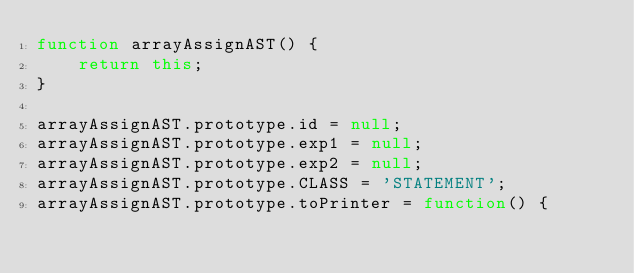<code> <loc_0><loc_0><loc_500><loc_500><_JavaScript_>function arrayAssignAST() {
    return this;
}

arrayAssignAST.prototype.id = null;
arrayAssignAST.prototype.exp1 = null;
arrayAssignAST.prototype.exp2 = null;
arrayAssignAST.prototype.CLASS = 'STATEMENT';
arrayAssignAST.prototype.toPrinter = function() {</code> 